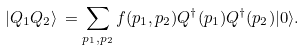<formula> <loc_0><loc_0><loc_500><loc_500>| Q _ { 1 } Q _ { 2 } \rangle \, = \sum _ { { p _ { 1 } } , { p _ { 2 } } } f ( { p _ { 1 } } , { p _ { 2 } } ) Q ^ { \dagger } ( { p _ { 1 } } ) Q ^ { \dagger } ( { p _ { 2 } } ) | 0 \rangle .</formula> 